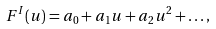<formula> <loc_0><loc_0><loc_500><loc_500>F ^ { I } ( u ) = a _ { 0 } + a _ { 1 } u + a _ { 2 } u ^ { 2 } + \dots ,</formula> 